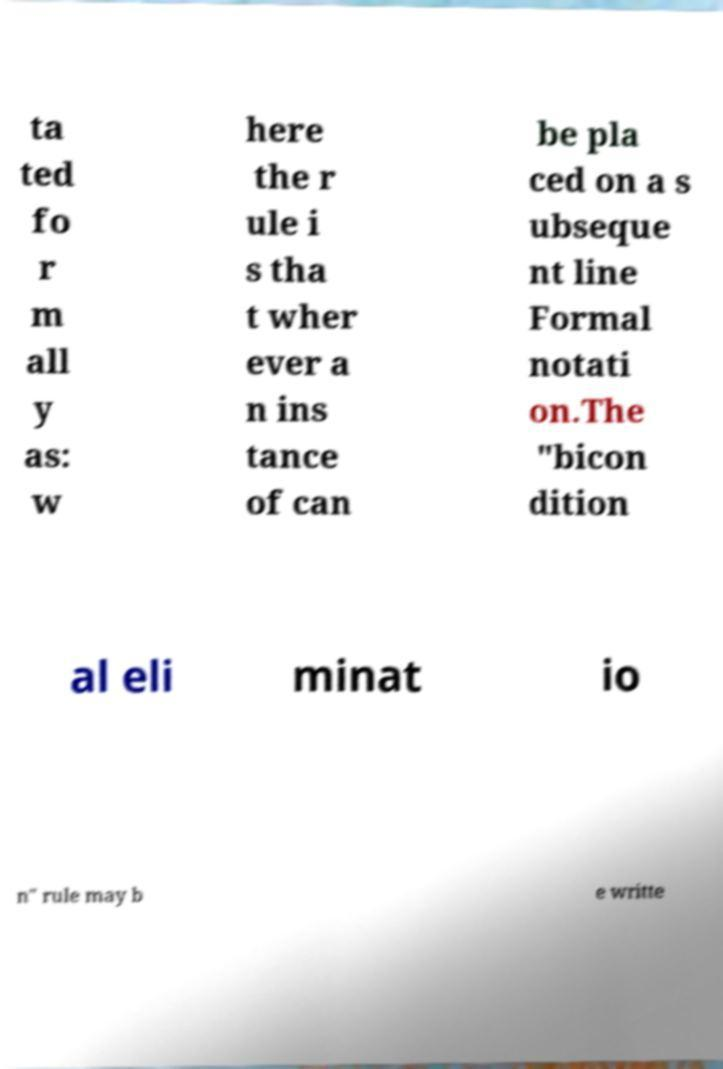I need the written content from this picture converted into text. Can you do that? ta ted fo r m all y as: w here the r ule i s tha t wher ever a n ins tance of can be pla ced on a s ubseque nt line Formal notati on.The "bicon dition al eli minat io n" rule may b e writte 